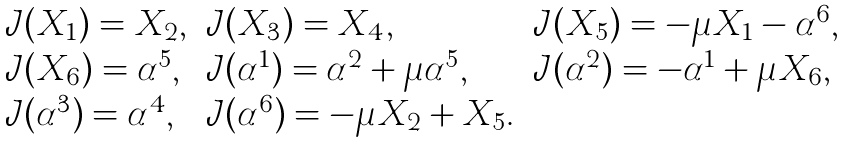Convert formula to latex. <formula><loc_0><loc_0><loc_500><loc_500>\begin{array} { l l l } \mathcal { J } ( X _ { 1 } ) = X _ { 2 } , & \mathcal { J } ( X _ { 3 } ) = X _ { 4 } , & \mathcal { J } ( X _ { 5 } ) = - \mu X _ { 1 } - \alpha ^ { 6 } , \\ \mathcal { J } ( X _ { 6 } ) = \alpha ^ { 5 } , & \mathcal { J } ( \alpha ^ { 1 } ) = \alpha ^ { 2 } + \mu \alpha ^ { 5 } , & \mathcal { J } ( \alpha ^ { 2 } ) = - \alpha ^ { 1 } + \mu X _ { 6 } , \\ \mathcal { J } ( \alpha ^ { 3 } ) = \alpha ^ { 4 } , & \mathcal { J } ( \alpha ^ { 6 } ) = - \mu X _ { 2 } + X _ { 5 } . \end{array}</formula> 